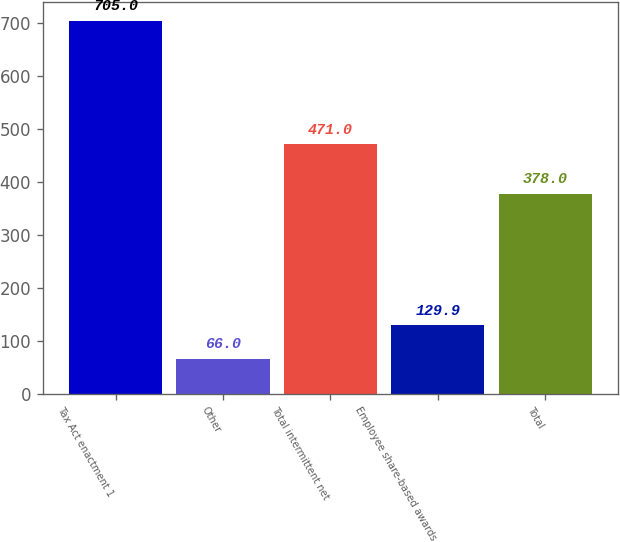Convert chart to OTSL. <chart><loc_0><loc_0><loc_500><loc_500><bar_chart><fcel>Tax Act enactment 1<fcel>Other<fcel>Total intermittent net<fcel>Employee share-based awards<fcel>Total<nl><fcel>705<fcel>66<fcel>471<fcel>129.9<fcel>378<nl></chart> 